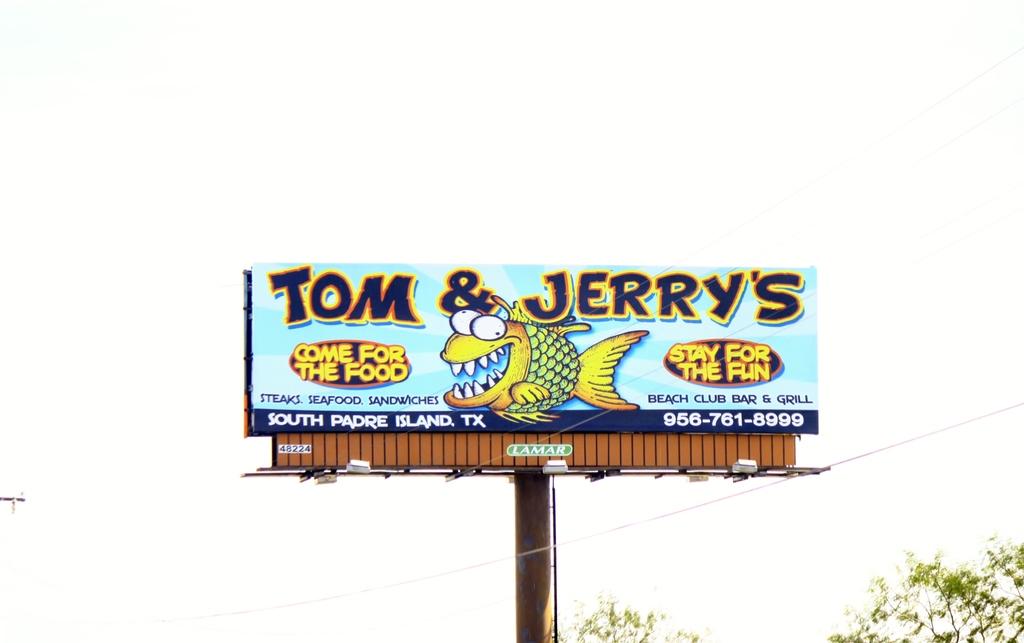What is wrote on the top left?
Give a very brief answer. Tom. 